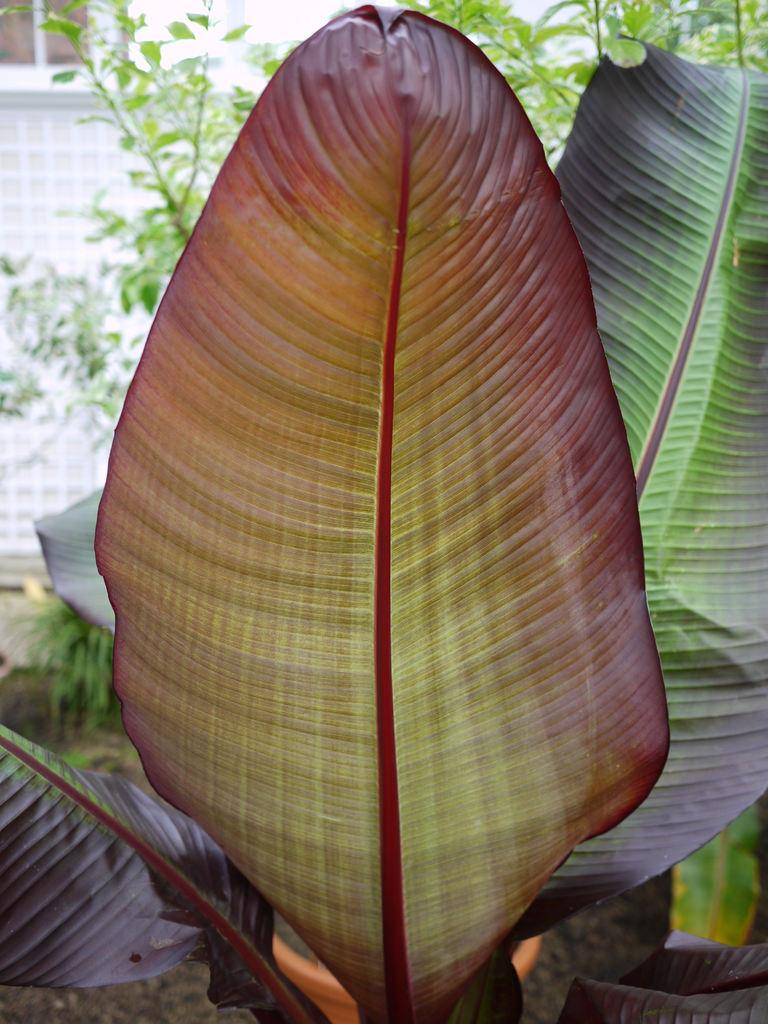What is located in the front of the image? There is a plant in the front of the image. What can be seen in the background of the image? There is a wall and a window in the background of the image. What type of vegetation is visible in the middle of the image? There is a tree visible in the middle of the image. Are there any police officers visible in the image? There are no police officers present in the image. What type of amusement can be seen in the middle of the image? There is no amusement present in the image; it features a tree. 